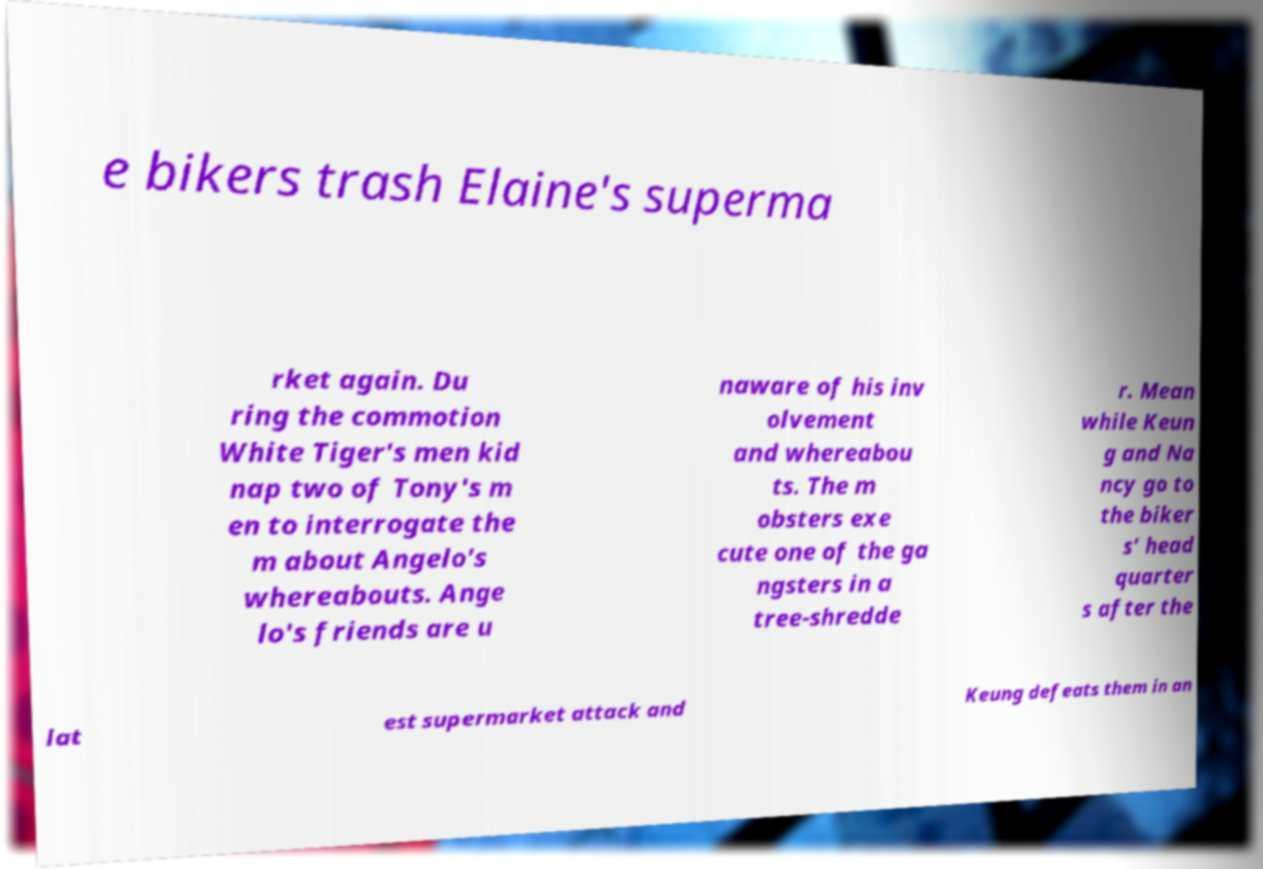What messages or text are displayed in this image? I need them in a readable, typed format. e bikers trash Elaine's superma rket again. Du ring the commotion White Tiger's men kid nap two of Tony's m en to interrogate the m about Angelo's whereabouts. Ange lo's friends are u naware of his inv olvement and whereabou ts. The m obsters exe cute one of the ga ngsters in a tree-shredde r. Mean while Keun g and Na ncy go to the biker s' head quarter s after the lat est supermarket attack and Keung defeats them in an 